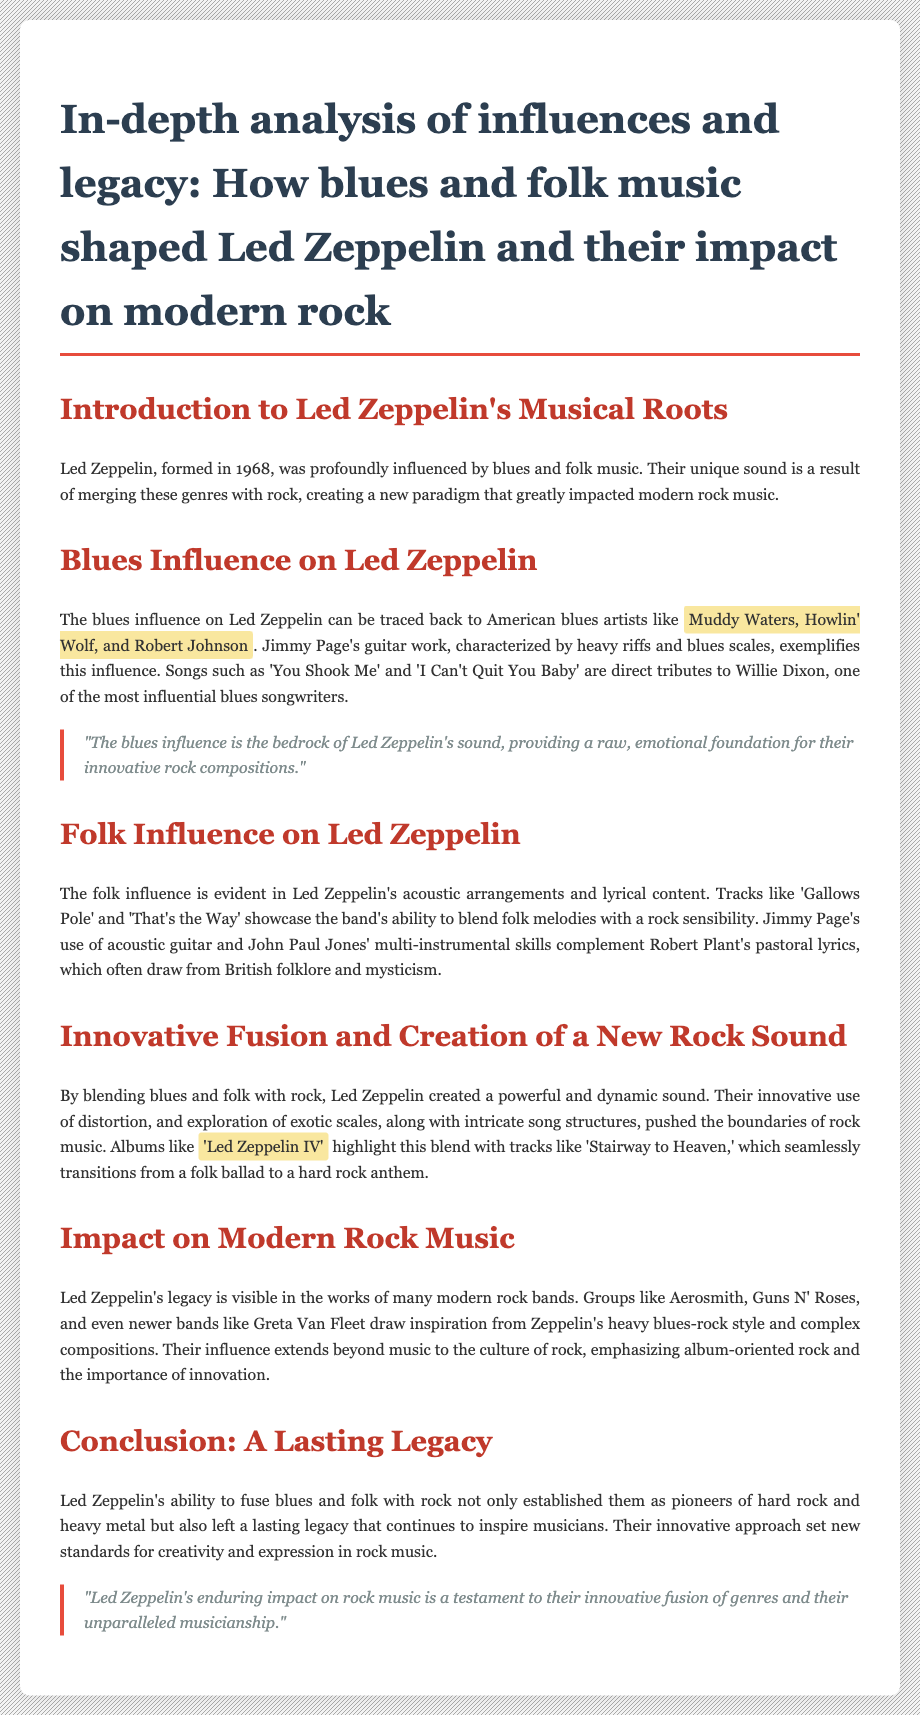What year was Led Zeppelin formed? The document states that Led Zeppelin was formed in 1968.
Answer: 1968 Which artists are mentioned as influences on Led Zeppelin's blues music? The document lists Muddy Waters, Howlin' Wolf, and Robert Johnson as influential blues artists.
Answer: Muddy Waters, Howlin' Wolf, and Robert Johnson What song is noted as a tribute to Willie Dixon? The document mentions 'You Shook Me' as a tribute to Willie Dixon.
Answer: 'You Shook Me' Which album features 'Stairway to Heaven'? The document identifies 'Led Zeppelin IV' as the album that features 'Stairway to Heaven.'
Answer: 'Led Zeppelin IV' How does the document describe Led Zeppelin's impact on modern rock music? It states that their legacy is visible in many modern rock bands.
Answer: Legacy visible in modern rock bands What musical elements did Led Zeppelin blend to create their sound? The document mentions the blending of blues and folk with rock.
Answer: Blues and folk with rock Which modern bands are mentioned as being influenced by Led Zeppelin? The document cites Aerosmith, Guns N' Roses, and Greta Van Fleet as influenced by Zeppelin.
Answer: Aerosmith, Guns N' Roses, and Greta Van Fleet What is emphasized about Led Zeppelin's approach to music? The document emphasizes their innovative approach set new standards for creativity and expression in rock music.
Answer: Innovative approach set new standards 